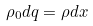Convert formula to latex. <formula><loc_0><loc_0><loc_500><loc_500>\rho _ { 0 } d q = \rho d x</formula> 